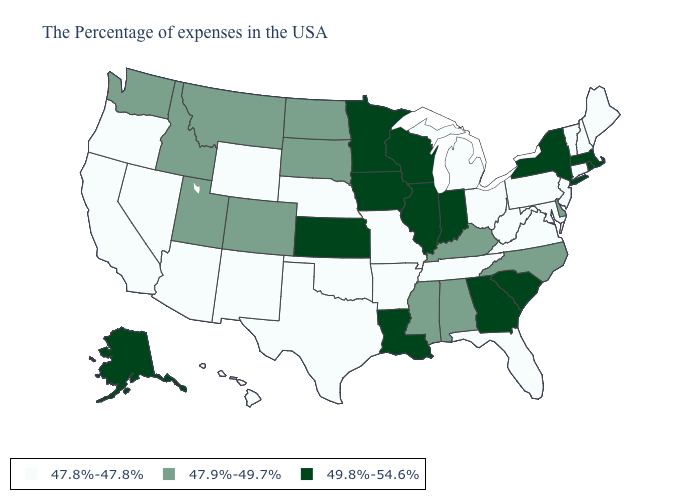What is the value of Utah?
Answer briefly. 47.9%-49.7%. What is the lowest value in states that border South Carolina?
Keep it brief. 47.9%-49.7%. Which states hav the highest value in the Northeast?
Short answer required. Massachusetts, Rhode Island, New York. What is the value of New York?
Be succinct. 49.8%-54.6%. Name the states that have a value in the range 49.8%-54.6%?
Answer briefly. Massachusetts, Rhode Island, New York, South Carolina, Georgia, Indiana, Wisconsin, Illinois, Louisiana, Minnesota, Iowa, Kansas, Alaska. Which states hav the highest value in the Northeast?
Quick response, please. Massachusetts, Rhode Island, New York. Does California have a lower value than Wisconsin?
Quick response, please. Yes. What is the value of Utah?
Write a very short answer. 47.9%-49.7%. What is the highest value in states that border Mississippi?
Give a very brief answer. 49.8%-54.6%. What is the value of Oregon?
Concise answer only. 47.8%-47.8%. Does the first symbol in the legend represent the smallest category?
Quick response, please. Yes. Which states have the lowest value in the Northeast?
Concise answer only. Maine, New Hampshire, Vermont, Connecticut, New Jersey, Pennsylvania. Name the states that have a value in the range 47.9%-49.7%?
Short answer required. Delaware, North Carolina, Kentucky, Alabama, Mississippi, South Dakota, North Dakota, Colorado, Utah, Montana, Idaho, Washington. What is the value of Maryland?
Quick response, please. 47.8%-47.8%. Among the states that border Rhode Island , does Massachusetts have the lowest value?
Concise answer only. No. 